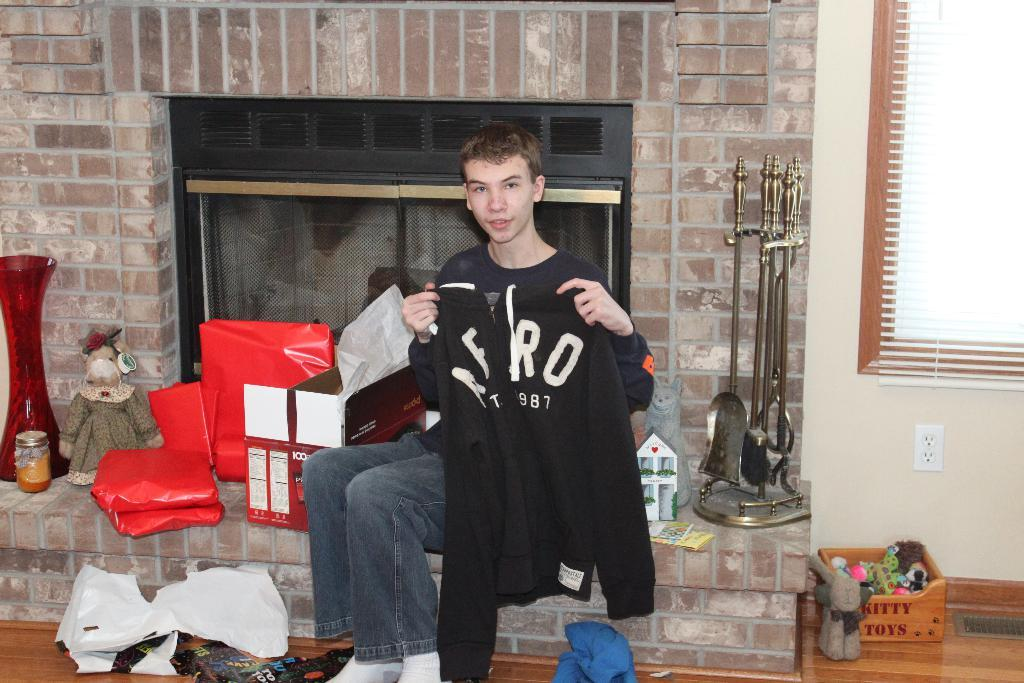<image>
Share a concise interpretation of the image provided. A man poses with his Aero sweater in front of a fireplace. 